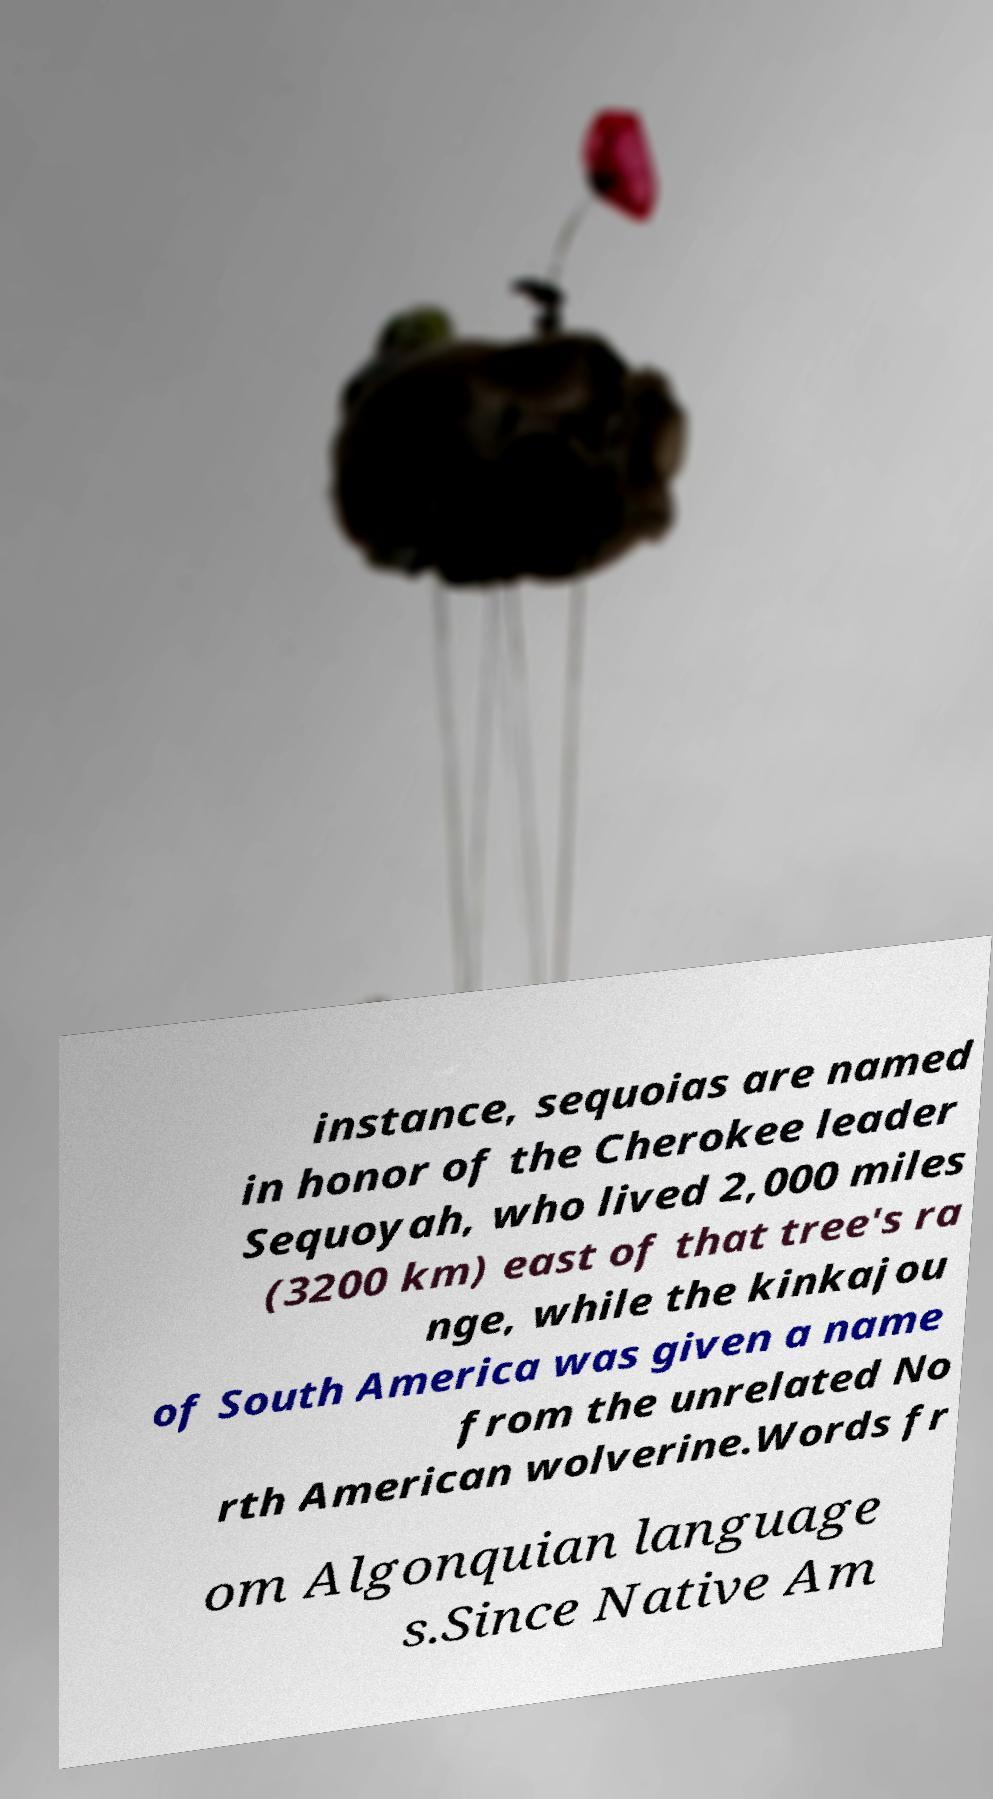There's text embedded in this image that I need extracted. Can you transcribe it verbatim? instance, sequoias are named in honor of the Cherokee leader Sequoyah, who lived 2,000 miles (3200 km) east of that tree's ra nge, while the kinkajou of South America was given a name from the unrelated No rth American wolverine.Words fr om Algonquian language s.Since Native Am 